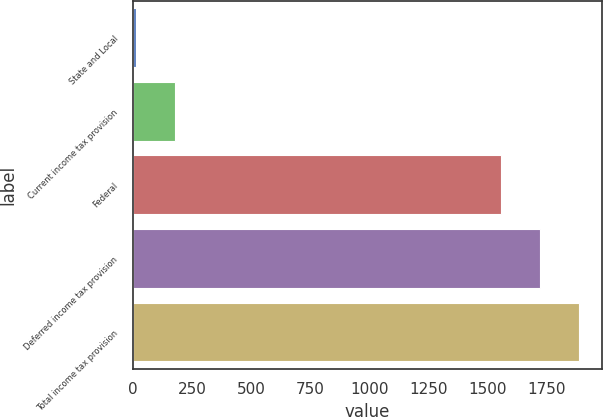Convert chart to OTSL. <chart><loc_0><loc_0><loc_500><loc_500><bar_chart><fcel>State and Local<fcel>Current income tax provision<fcel>Federal<fcel>Deferred income tax provision<fcel>Total income tax provision<nl><fcel>10<fcel>175.2<fcel>1559<fcel>1724.2<fcel>1889.4<nl></chart> 